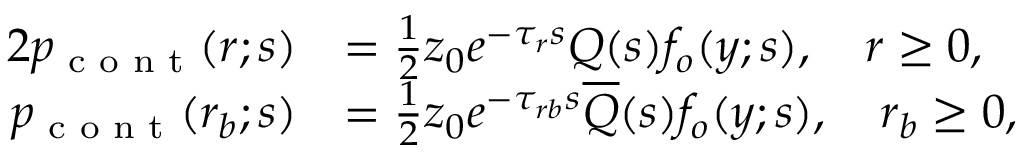<formula> <loc_0><loc_0><loc_500><loc_500>\begin{array} { r l r l } { { 2 } p _ { c o n t } ( r ; s ) } & { = \frac { 1 } { 2 } z _ { 0 } e ^ { - \tau _ { r } s } Q ( s ) f _ { o } ( y ; s ) , \quad r \geq 0 , } & \\ { p _ { c o n t } ( r _ { b } ; s ) } & { = \frac { 1 } { 2 } z _ { 0 } e ^ { - \tau _ { r b } s } \overline { Q } ( s ) f _ { o } ( y ; s ) , \quad r _ { b } \geq 0 , } & \end{array}</formula> 